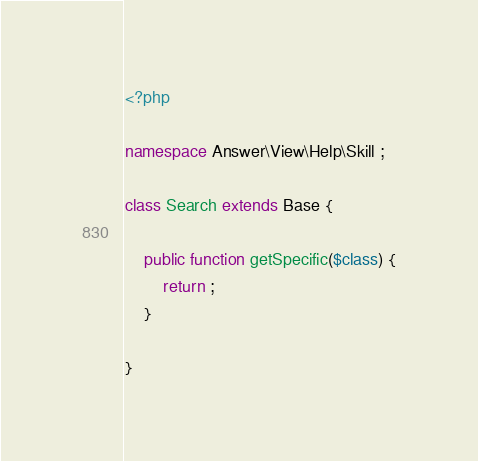Convert code to text. <code><loc_0><loc_0><loc_500><loc_500><_PHP_><?php

namespace Answer\View\Help\Skill ;

class Search extends Base {
    
    public function getSpecific($class) {
        return ;
    }
    
}
</code> 